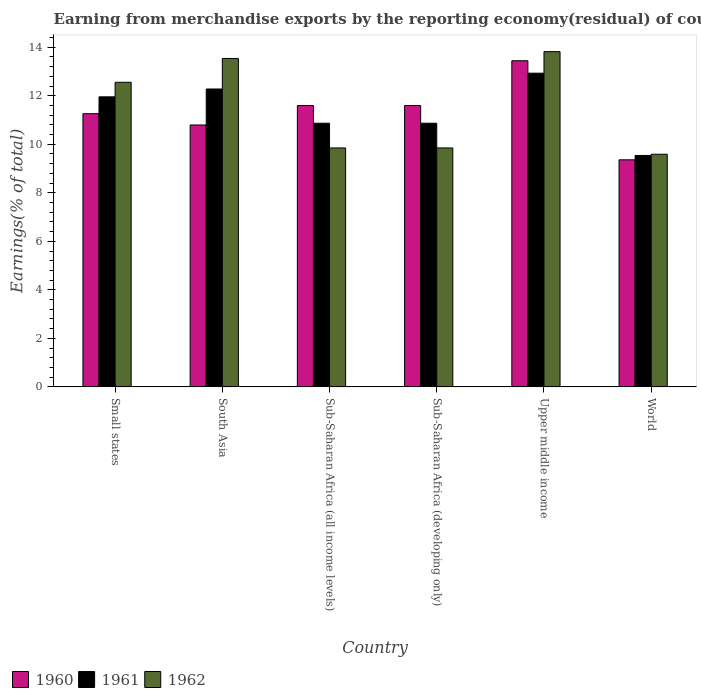How many different coloured bars are there?
Offer a very short reply. 3. How many groups of bars are there?
Your response must be concise. 6. Are the number of bars per tick equal to the number of legend labels?
Offer a very short reply. Yes. How many bars are there on the 1st tick from the left?
Offer a terse response. 3. How many bars are there on the 5th tick from the right?
Your answer should be very brief. 3. What is the label of the 6th group of bars from the left?
Ensure brevity in your answer.  World. In how many cases, is the number of bars for a given country not equal to the number of legend labels?
Provide a succinct answer. 0. What is the percentage of amount earned from merchandise exports in 1960 in World?
Keep it short and to the point. 9.36. Across all countries, what is the maximum percentage of amount earned from merchandise exports in 1960?
Keep it short and to the point. 13.44. Across all countries, what is the minimum percentage of amount earned from merchandise exports in 1961?
Make the answer very short. 9.54. In which country was the percentage of amount earned from merchandise exports in 1961 maximum?
Offer a very short reply. Upper middle income. What is the total percentage of amount earned from merchandise exports in 1961 in the graph?
Offer a very short reply. 68.44. What is the difference between the percentage of amount earned from merchandise exports in 1960 in Small states and that in Sub-Saharan Africa (all income levels)?
Offer a very short reply. -0.34. What is the difference between the percentage of amount earned from merchandise exports in 1962 in Small states and the percentage of amount earned from merchandise exports in 1961 in Upper middle income?
Keep it short and to the point. -0.38. What is the average percentage of amount earned from merchandise exports in 1960 per country?
Offer a terse response. 11.34. What is the difference between the percentage of amount earned from merchandise exports of/in 1960 and percentage of amount earned from merchandise exports of/in 1962 in Sub-Saharan Africa (all income levels)?
Your answer should be compact. 1.75. In how many countries, is the percentage of amount earned from merchandise exports in 1961 greater than 4 %?
Keep it short and to the point. 6. What is the ratio of the percentage of amount earned from merchandise exports in 1960 in Sub-Saharan Africa (developing only) to that in Upper middle income?
Offer a very short reply. 0.86. Is the percentage of amount earned from merchandise exports in 1960 in South Asia less than that in Sub-Saharan Africa (all income levels)?
Offer a terse response. Yes. What is the difference between the highest and the second highest percentage of amount earned from merchandise exports in 1962?
Ensure brevity in your answer.  0.98. What is the difference between the highest and the lowest percentage of amount earned from merchandise exports in 1961?
Make the answer very short. 3.39. In how many countries, is the percentage of amount earned from merchandise exports in 1962 greater than the average percentage of amount earned from merchandise exports in 1962 taken over all countries?
Provide a succinct answer. 3. Is the sum of the percentage of amount earned from merchandise exports in 1961 in Upper middle income and World greater than the maximum percentage of amount earned from merchandise exports in 1962 across all countries?
Your answer should be compact. Yes. What does the 2nd bar from the left in World represents?
Offer a very short reply. 1961. Is it the case that in every country, the sum of the percentage of amount earned from merchandise exports in 1962 and percentage of amount earned from merchandise exports in 1960 is greater than the percentage of amount earned from merchandise exports in 1961?
Your response must be concise. Yes. How many bars are there?
Keep it short and to the point. 18. What is the difference between two consecutive major ticks on the Y-axis?
Provide a succinct answer. 2. Does the graph contain any zero values?
Provide a succinct answer. No. Where does the legend appear in the graph?
Ensure brevity in your answer.  Bottom left. What is the title of the graph?
Keep it short and to the point. Earning from merchandise exports by the reporting economy(residual) of countries. What is the label or title of the X-axis?
Your answer should be compact. Country. What is the label or title of the Y-axis?
Offer a very short reply. Earnings(% of total). What is the Earnings(% of total) of 1960 in Small states?
Your answer should be compact. 11.26. What is the Earnings(% of total) in 1961 in Small states?
Provide a succinct answer. 11.96. What is the Earnings(% of total) of 1962 in Small states?
Provide a succinct answer. 12.56. What is the Earnings(% of total) of 1960 in South Asia?
Your answer should be very brief. 10.8. What is the Earnings(% of total) in 1961 in South Asia?
Provide a short and direct response. 12.28. What is the Earnings(% of total) in 1962 in South Asia?
Offer a terse response. 13.54. What is the Earnings(% of total) of 1960 in Sub-Saharan Africa (all income levels)?
Ensure brevity in your answer.  11.6. What is the Earnings(% of total) of 1961 in Sub-Saharan Africa (all income levels)?
Your response must be concise. 10.87. What is the Earnings(% of total) in 1962 in Sub-Saharan Africa (all income levels)?
Give a very brief answer. 9.85. What is the Earnings(% of total) of 1960 in Sub-Saharan Africa (developing only)?
Your response must be concise. 11.6. What is the Earnings(% of total) in 1961 in Sub-Saharan Africa (developing only)?
Offer a very short reply. 10.87. What is the Earnings(% of total) in 1962 in Sub-Saharan Africa (developing only)?
Your response must be concise. 9.85. What is the Earnings(% of total) of 1960 in Upper middle income?
Your answer should be compact. 13.44. What is the Earnings(% of total) in 1961 in Upper middle income?
Provide a short and direct response. 12.93. What is the Earnings(% of total) in 1962 in Upper middle income?
Provide a succinct answer. 13.82. What is the Earnings(% of total) in 1960 in World?
Your response must be concise. 9.36. What is the Earnings(% of total) in 1961 in World?
Your response must be concise. 9.54. What is the Earnings(% of total) in 1962 in World?
Provide a succinct answer. 9.59. Across all countries, what is the maximum Earnings(% of total) in 1960?
Your response must be concise. 13.44. Across all countries, what is the maximum Earnings(% of total) of 1961?
Your answer should be compact. 12.93. Across all countries, what is the maximum Earnings(% of total) in 1962?
Ensure brevity in your answer.  13.82. Across all countries, what is the minimum Earnings(% of total) of 1960?
Provide a succinct answer. 9.36. Across all countries, what is the minimum Earnings(% of total) in 1961?
Offer a terse response. 9.54. Across all countries, what is the minimum Earnings(% of total) of 1962?
Offer a terse response. 9.59. What is the total Earnings(% of total) in 1960 in the graph?
Provide a succinct answer. 68.05. What is the total Earnings(% of total) in 1961 in the graph?
Provide a succinct answer. 68.44. What is the total Earnings(% of total) of 1962 in the graph?
Keep it short and to the point. 69.2. What is the difference between the Earnings(% of total) in 1960 in Small states and that in South Asia?
Ensure brevity in your answer.  0.47. What is the difference between the Earnings(% of total) of 1961 in Small states and that in South Asia?
Your answer should be compact. -0.32. What is the difference between the Earnings(% of total) of 1962 in Small states and that in South Asia?
Ensure brevity in your answer.  -0.98. What is the difference between the Earnings(% of total) in 1960 in Small states and that in Sub-Saharan Africa (all income levels)?
Provide a short and direct response. -0.34. What is the difference between the Earnings(% of total) of 1961 in Small states and that in Sub-Saharan Africa (all income levels)?
Make the answer very short. 1.09. What is the difference between the Earnings(% of total) in 1962 in Small states and that in Sub-Saharan Africa (all income levels)?
Offer a very short reply. 2.71. What is the difference between the Earnings(% of total) of 1960 in Small states and that in Sub-Saharan Africa (developing only)?
Provide a succinct answer. -0.34. What is the difference between the Earnings(% of total) of 1961 in Small states and that in Sub-Saharan Africa (developing only)?
Make the answer very short. 1.09. What is the difference between the Earnings(% of total) of 1962 in Small states and that in Sub-Saharan Africa (developing only)?
Keep it short and to the point. 2.71. What is the difference between the Earnings(% of total) of 1960 in Small states and that in Upper middle income?
Keep it short and to the point. -2.18. What is the difference between the Earnings(% of total) of 1961 in Small states and that in Upper middle income?
Your answer should be very brief. -0.98. What is the difference between the Earnings(% of total) of 1962 in Small states and that in Upper middle income?
Provide a short and direct response. -1.26. What is the difference between the Earnings(% of total) of 1960 in Small states and that in World?
Provide a succinct answer. 1.9. What is the difference between the Earnings(% of total) of 1961 in Small states and that in World?
Offer a terse response. 2.42. What is the difference between the Earnings(% of total) of 1962 in Small states and that in World?
Your response must be concise. 2.97. What is the difference between the Earnings(% of total) of 1960 in South Asia and that in Sub-Saharan Africa (all income levels)?
Offer a very short reply. -0.8. What is the difference between the Earnings(% of total) of 1961 in South Asia and that in Sub-Saharan Africa (all income levels)?
Make the answer very short. 1.41. What is the difference between the Earnings(% of total) of 1962 in South Asia and that in Sub-Saharan Africa (all income levels)?
Provide a short and direct response. 3.69. What is the difference between the Earnings(% of total) in 1960 in South Asia and that in Sub-Saharan Africa (developing only)?
Provide a short and direct response. -0.8. What is the difference between the Earnings(% of total) in 1961 in South Asia and that in Sub-Saharan Africa (developing only)?
Offer a terse response. 1.41. What is the difference between the Earnings(% of total) in 1962 in South Asia and that in Sub-Saharan Africa (developing only)?
Your response must be concise. 3.69. What is the difference between the Earnings(% of total) in 1960 in South Asia and that in Upper middle income?
Offer a very short reply. -2.65. What is the difference between the Earnings(% of total) in 1961 in South Asia and that in Upper middle income?
Your answer should be compact. -0.65. What is the difference between the Earnings(% of total) of 1962 in South Asia and that in Upper middle income?
Provide a succinct answer. -0.28. What is the difference between the Earnings(% of total) of 1960 in South Asia and that in World?
Keep it short and to the point. 1.44. What is the difference between the Earnings(% of total) in 1961 in South Asia and that in World?
Ensure brevity in your answer.  2.74. What is the difference between the Earnings(% of total) of 1962 in South Asia and that in World?
Make the answer very short. 3.95. What is the difference between the Earnings(% of total) in 1961 in Sub-Saharan Africa (all income levels) and that in Sub-Saharan Africa (developing only)?
Your answer should be compact. 0. What is the difference between the Earnings(% of total) of 1960 in Sub-Saharan Africa (all income levels) and that in Upper middle income?
Keep it short and to the point. -1.85. What is the difference between the Earnings(% of total) in 1961 in Sub-Saharan Africa (all income levels) and that in Upper middle income?
Offer a terse response. -2.06. What is the difference between the Earnings(% of total) in 1962 in Sub-Saharan Africa (all income levels) and that in Upper middle income?
Ensure brevity in your answer.  -3.97. What is the difference between the Earnings(% of total) in 1960 in Sub-Saharan Africa (all income levels) and that in World?
Provide a succinct answer. 2.24. What is the difference between the Earnings(% of total) in 1961 in Sub-Saharan Africa (all income levels) and that in World?
Keep it short and to the point. 1.33. What is the difference between the Earnings(% of total) in 1962 in Sub-Saharan Africa (all income levels) and that in World?
Provide a succinct answer. 0.26. What is the difference between the Earnings(% of total) of 1960 in Sub-Saharan Africa (developing only) and that in Upper middle income?
Your answer should be very brief. -1.85. What is the difference between the Earnings(% of total) in 1961 in Sub-Saharan Africa (developing only) and that in Upper middle income?
Ensure brevity in your answer.  -2.06. What is the difference between the Earnings(% of total) of 1962 in Sub-Saharan Africa (developing only) and that in Upper middle income?
Give a very brief answer. -3.97. What is the difference between the Earnings(% of total) of 1960 in Sub-Saharan Africa (developing only) and that in World?
Offer a very short reply. 2.24. What is the difference between the Earnings(% of total) of 1961 in Sub-Saharan Africa (developing only) and that in World?
Give a very brief answer. 1.33. What is the difference between the Earnings(% of total) of 1962 in Sub-Saharan Africa (developing only) and that in World?
Provide a succinct answer. 0.26. What is the difference between the Earnings(% of total) in 1960 in Upper middle income and that in World?
Make the answer very short. 4.08. What is the difference between the Earnings(% of total) in 1961 in Upper middle income and that in World?
Make the answer very short. 3.39. What is the difference between the Earnings(% of total) of 1962 in Upper middle income and that in World?
Your answer should be very brief. 4.23. What is the difference between the Earnings(% of total) of 1960 in Small states and the Earnings(% of total) of 1961 in South Asia?
Your answer should be very brief. -1.02. What is the difference between the Earnings(% of total) in 1960 in Small states and the Earnings(% of total) in 1962 in South Asia?
Offer a very short reply. -2.28. What is the difference between the Earnings(% of total) of 1961 in Small states and the Earnings(% of total) of 1962 in South Asia?
Your response must be concise. -1.58. What is the difference between the Earnings(% of total) in 1960 in Small states and the Earnings(% of total) in 1961 in Sub-Saharan Africa (all income levels)?
Make the answer very short. 0.39. What is the difference between the Earnings(% of total) in 1960 in Small states and the Earnings(% of total) in 1962 in Sub-Saharan Africa (all income levels)?
Keep it short and to the point. 1.41. What is the difference between the Earnings(% of total) in 1961 in Small states and the Earnings(% of total) in 1962 in Sub-Saharan Africa (all income levels)?
Your answer should be very brief. 2.11. What is the difference between the Earnings(% of total) of 1960 in Small states and the Earnings(% of total) of 1961 in Sub-Saharan Africa (developing only)?
Offer a terse response. 0.39. What is the difference between the Earnings(% of total) in 1960 in Small states and the Earnings(% of total) in 1962 in Sub-Saharan Africa (developing only)?
Give a very brief answer. 1.41. What is the difference between the Earnings(% of total) in 1961 in Small states and the Earnings(% of total) in 1962 in Sub-Saharan Africa (developing only)?
Provide a short and direct response. 2.11. What is the difference between the Earnings(% of total) in 1960 in Small states and the Earnings(% of total) in 1961 in Upper middle income?
Offer a terse response. -1.67. What is the difference between the Earnings(% of total) of 1960 in Small states and the Earnings(% of total) of 1962 in Upper middle income?
Offer a terse response. -2.56. What is the difference between the Earnings(% of total) in 1961 in Small states and the Earnings(% of total) in 1962 in Upper middle income?
Provide a short and direct response. -1.86. What is the difference between the Earnings(% of total) in 1960 in Small states and the Earnings(% of total) in 1961 in World?
Ensure brevity in your answer.  1.72. What is the difference between the Earnings(% of total) in 1960 in Small states and the Earnings(% of total) in 1962 in World?
Ensure brevity in your answer.  1.67. What is the difference between the Earnings(% of total) of 1961 in Small states and the Earnings(% of total) of 1962 in World?
Keep it short and to the point. 2.37. What is the difference between the Earnings(% of total) in 1960 in South Asia and the Earnings(% of total) in 1961 in Sub-Saharan Africa (all income levels)?
Provide a succinct answer. -0.07. What is the difference between the Earnings(% of total) in 1960 in South Asia and the Earnings(% of total) in 1962 in Sub-Saharan Africa (all income levels)?
Make the answer very short. 0.95. What is the difference between the Earnings(% of total) of 1961 in South Asia and the Earnings(% of total) of 1962 in Sub-Saharan Africa (all income levels)?
Give a very brief answer. 2.43. What is the difference between the Earnings(% of total) in 1960 in South Asia and the Earnings(% of total) in 1961 in Sub-Saharan Africa (developing only)?
Provide a short and direct response. -0.07. What is the difference between the Earnings(% of total) of 1960 in South Asia and the Earnings(% of total) of 1962 in Sub-Saharan Africa (developing only)?
Your answer should be compact. 0.95. What is the difference between the Earnings(% of total) of 1961 in South Asia and the Earnings(% of total) of 1962 in Sub-Saharan Africa (developing only)?
Your answer should be compact. 2.43. What is the difference between the Earnings(% of total) in 1960 in South Asia and the Earnings(% of total) in 1961 in Upper middle income?
Keep it short and to the point. -2.14. What is the difference between the Earnings(% of total) of 1960 in South Asia and the Earnings(% of total) of 1962 in Upper middle income?
Your answer should be very brief. -3.02. What is the difference between the Earnings(% of total) in 1961 in South Asia and the Earnings(% of total) in 1962 in Upper middle income?
Your answer should be compact. -1.54. What is the difference between the Earnings(% of total) of 1960 in South Asia and the Earnings(% of total) of 1961 in World?
Make the answer very short. 1.26. What is the difference between the Earnings(% of total) of 1960 in South Asia and the Earnings(% of total) of 1962 in World?
Make the answer very short. 1.21. What is the difference between the Earnings(% of total) of 1961 in South Asia and the Earnings(% of total) of 1962 in World?
Offer a terse response. 2.69. What is the difference between the Earnings(% of total) of 1960 in Sub-Saharan Africa (all income levels) and the Earnings(% of total) of 1961 in Sub-Saharan Africa (developing only)?
Your response must be concise. 0.73. What is the difference between the Earnings(% of total) of 1960 in Sub-Saharan Africa (all income levels) and the Earnings(% of total) of 1962 in Sub-Saharan Africa (developing only)?
Make the answer very short. 1.75. What is the difference between the Earnings(% of total) of 1961 in Sub-Saharan Africa (all income levels) and the Earnings(% of total) of 1962 in Sub-Saharan Africa (developing only)?
Provide a short and direct response. 1.02. What is the difference between the Earnings(% of total) of 1960 in Sub-Saharan Africa (all income levels) and the Earnings(% of total) of 1961 in Upper middle income?
Ensure brevity in your answer.  -1.33. What is the difference between the Earnings(% of total) in 1960 in Sub-Saharan Africa (all income levels) and the Earnings(% of total) in 1962 in Upper middle income?
Provide a short and direct response. -2.22. What is the difference between the Earnings(% of total) in 1961 in Sub-Saharan Africa (all income levels) and the Earnings(% of total) in 1962 in Upper middle income?
Keep it short and to the point. -2.95. What is the difference between the Earnings(% of total) of 1960 in Sub-Saharan Africa (all income levels) and the Earnings(% of total) of 1961 in World?
Offer a very short reply. 2.06. What is the difference between the Earnings(% of total) of 1960 in Sub-Saharan Africa (all income levels) and the Earnings(% of total) of 1962 in World?
Give a very brief answer. 2.01. What is the difference between the Earnings(% of total) in 1961 in Sub-Saharan Africa (all income levels) and the Earnings(% of total) in 1962 in World?
Provide a short and direct response. 1.28. What is the difference between the Earnings(% of total) of 1960 in Sub-Saharan Africa (developing only) and the Earnings(% of total) of 1961 in Upper middle income?
Your response must be concise. -1.33. What is the difference between the Earnings(% of total) in 1960 in Sub-Saharan Africa (developing only) and the Earnings(% of total) in 1962 in Upper middle income?
Make the answer very short. -2.22. What is the difference between the Earnings(% of total) of 1961 in Sub-Saharan Africa (developing only) and the Earnings(% of total) of 1962 in Upper middle income?
Offer a terse response. -2.95. What is the difference between the Earnings(% of total) in 1960 in Sub-Saharan Africa (developing only) and the Earnings(% of total) in 1961 in World?
Keep it short and to the point. 2.06. What is the difference between the Earnings(% of total) in 1960 in Sub-Saharan Africa (developing only) and the Earnings(% of total) in 1962 in World?
Your response must be concise. 2.01. What is the difference between the Earnings(% of total) in 1961 in Sub-Saharan Africa (developing only) and the Earnings(% of total) in 1962 in World?
Offer a very short reply. 1.28. What is the difference between the Earnings(% of total) in 1960 in Upper middle income and the Earnings(% of total) in 1961 in World?
Your answer should be compact. 3.9. What is the difference between the Earnings(% of total) in 1960 in Upper middle income and the Earnings(% of total) in 1962 in World?
Ensure brevity in your answer.  3.85. What is the difference between the Earnings(% of total) of 1961 in Upper middle income and the Earnings(% of total) of 1962 in World?
Keep it short and to the point. 3.34. What is the average Earnings(% of total) in 1960 per country?
Provide a succinct answer. 11.34. What is the average Earnings(% of total) in 1961 per country?
Make the answer very short. 11.41. What is the average Earnings(% of total) in 1962 per country?
Keep it short and to the point. 11.53. What is the difference between the Earnings(% of total) in 1960 and Earnings(% of total) in 1961 in Small states?
Offer a terse response. -0.69. What is the difference between the Earnings(% of total) in 1960 and Earnings(% of total) in 1962 in Small states?
Provide a short and direct response. -1.29. What is the difference between the Earnings(% of total) in 1961 and Earnings(% of total) in 1962 in Small states?
Make the answer very short. -0.6. What is the difference between the Earnings(% of total) of 1960 and Earnings(% of total) of 1961 in South Asia?
Give a very brief answer. -1.48. What is the difference between the Earnings(% of total) of 1960 and Earnings(% of total) of 1962 in South Asia?
Offer a terse response. -2.74. What is the difference between the Earnings(% of total) of 1961 and Earnings(% of total) of 1962 in South Asia?
Provide a succinct answer. -1.26. What is the difference between the Earnings(% of total) in 1960 and Earnings(% of total) in 1961 in Sub-Saharan Africa (all income levels)?
Your answer should be compact. 0.73. What is the difference between the Earnings(% of total) in 1960 and Earnings(% of total) in 1962 in Sub-Saharan Africa (all income levels)?
Keep it short and to the point. 1.75. What is the difference between the Earnings(% of total) in 1961 and Earnings(% of total) in 1962 in Sub-Saharan Africa (all income levels)?
Offer a terse response. 1.02. What is the difference between the Earnings(% of total) of 1960 and Earnings(% of total) of 1961 in Sub-Saharan Africa (developing only)?
Your answer should be very brief. 0.73. What is the difference between the Earnings(% of total) in 1960 and Earnings(% of total) in 1962 in Sub-Saharan Africa (developing only)?
Ensure brevity in your answer.  1.75. What is the difference between the Earnings(% of total) in 1961 and Earnings(% of total) in 1962 in Sub-Saharan Africa (developing only)?
Keep it short and to the point. 1.02. What is the difference between the Earnings(% of total) of 1960 and Earnings(% of total) of 1961 in Upper middle income?
Make the answer very short. 0.51. What is the difference between the Earnings(% of total) of 1960 and Earnings(% of total) of 1962 in Upper middle income?
Give a very brief answer. -0.38. What is the difference between the Earnings(% of total) in 1961 and Earnings(% of total) in 1962 in Upper middle income?
Provide a short and direct response. -0.89. What is the difference between the Earnings(% of total) in 1960 and Earnings(% of total) in 1961 in World?
Offer a very short reply. -0.18. What is the difference between the Earnings(% of total) in 1960 and Earnings(% of total) in 1962 in World?
Ensure brevity in your answer.  -0.23. What is the difference between the Earnings(% of total) in 1961 and Earnings(% of total) in 1962 in World?
Your answer should be compact. -0.05. What is the ratio of the Earnings(% of total) of 1960 in Small states to that in South Asia?
Your answer should be very brief. 1.04. What is the ratio of the Earnings(% of total) of 1961 in Small states to that in South Asia?
Make the answer very short. 0.97. What is the ratio of the Earnings(% of total) of 1962 in Small states to that in South Asia?
Ensure brevity in your answer.  0.93. What is the ratio of the Earnings(% of total) of 1960 in Small states to that in Sub-Saharan Africa (all income levels)?
Provide a succinct answer. 0.97. What is the ratio of the Earnings(% of total) in 1961 in Small states to that in Sub-Saharan Africa (all income levels)?
Provide a succinct answer. 1.1. What is the ratio of the Earnings(% of total) of 1962 in Small states to that in Sub-Saharan Africa (all income levels)?
Provide a succinct answer. 1.27. What is the ratio of the Earnings(% of total) in 1960 in Small states to that in Sub-Saharan Africa (developing only)?
Offer a terse response. 0.97. What is the ratio of the Earnings(% of total) of 1961 in Small states to that in Sub-Saharan Africa (developing only)?
Provide a short and direct response. 1.1. What is the ratio of the Earnings(% of total) in 1962 in Small states to that in Sub-Saharan Africa (developing only)?
Keep it short and to the point. 1.27. What is the ratio of the Earnings(% of total) of 1960 in Small states to that in Upper middle income?
Your answer should be compact. 0.84. What is the ratio of the Earnings(% of total) of 1961 in Small states to that in Upper middle income?
Provide a short and direct response. 0.92. What is the ratio of the Earnings(% of total) of 1962 in Small states to that in Upper middle income?
Your answer should be very brief. 0.91. What is the ratio of the Earnings(% of total) of 1960 in Small states to that in World?
Provide a short and direct response. 1.2. What is the ratio of the Earnings(% of total) of 1961 in Small states to that in World?
Provide a short and direct response. 1.25. What is the ratio of the Earnings(% of total) of 1962 in Small states to that in World?
Make the answer very short. 1.31. What is the ratio of the Earnings(% of total) in 1960 in South Asia to that in Sub-Saharan Africa (all income levels)?
Give a very brief answer. 0.93. What is the ratio of the Earnings(% of total) of 1961 in South Asia to that in Sub-Saharan Africa (all income levels)?
Make the answer very short. 1.13. What is the ratio of the Earnings(% of total) in 1962 in South Asia to that in Sub-Saharan Africa (all income levels)?
Offer a terse response. 1.37. What is the ratio of the Earnings(% of total) of 1960 in South Asia to that in Sub-Saharan Africa (developing only)?
Your response must be concise. 0.93. What is the ratio of the Earnings(% of total) of 1961 in South Asia to that in Sub-Saharan Africa (developing only)?
Offer a terse response. 1.13. What is the ratio of the Earnings(% of total) in 1962 in South Asia to that in Sub-Saharan Africa (developing only)?
Provide a succinct answer. 1.37. What is the ratio of the Earnings(% of total) in 1960 in South Asia to that in Upper middle income?
Your answer should be compact. 0.8. What is the ratio of the Earnings(% of total) of 1961 in South Asia to that in Upper middle income?
Offer a very short reply. 0.95. What is the ratio of the Earnings(% of total) of 1962 in South Asia to that in Upper middle income?
Give a very brief answer. 0.98. What is the ratio of the Earnings(% of total) of 1960 in South Asia to that in World?
Your answer should be very brief. 1.15. What is the ratio of the Earnings(% of total) in 1961 in South Asia to that in World?
Your answer should be very brief. 1.29. What is the ratio of the Earnings(% of total) in 1962 in South Asia to that in World?
Give a very brief answer. 1.41. What is the ratio of the Earnings(% of total) of 1960 in Sub-Saharan Africa (all income levels) to that in Upper middle income?
Your response must be concise. 0.86. What is the ratio of the Earnings(% of total) of 1961 in Sub-Saharan Africa (all income levels) to that in Upper middle income?
Provide a succinct answer. 0.84. What is the ratio of the Earnings(% of total) in 1962 in Sub-Saharan Africa (all income levels) to that in Upper middle income?
Provide a succinct answer. 0.71. What is the ratio of the Earnings(% of total) in 1960 in Sub-Saharan Africa (all income levels) to that in World?
Your response must be concise. 1.24. What is the ratio of the Earnings(% of total) of 1961 in Sub-Saharan Africa (all income levels) to that in World?
Provide a short and direct response. 1.14. What is the ratio of the Earnings(% of total) in 1962 in Sub-Saharan Africa (all income levels) to that in World?
Make the answer very short. 1.03. What is the ratio of the Earnings(% of total) in 1960 in Sub-Saharan Africa (developing only) to that in Upper middle income?
Provide a short and direct response. 0.86. What is the ratio of the Earnings(% of total) of 1961 in Sub-Saharan Africa (developing only) to that in Upper middle income?
Provide a short and direct response. 0.84. What is the ratio of the Earnings(% of total) in 1962 in Sub-Saharan Africa (developing only) to that in Upper middle income?
Provide a succinct answer. 0.71. What is the ratio of the Earnings(% of total) in 1960 in Sub-Saharan Africa (developing only) to that in World?
Offer a terse response. 1.24. What is the ratio of the Earnings(% of total) of 1961 in Sub-Saharan Africa (developing only) to that in World?
Make the answer very short. 1.14. What is the ratio of the Earnings(% of total) in 1962 in Sub-Saharan Africa (developing only) to that in World?
Your response must be concise. 1.03. What is the ratio of the Earnings(% of total) of 1960 in Upper middle income to that in World?
Your answer should be very brief. 1.44. What is the ratio of the Earnings(% of total) of 1961 in Upper middle income to that in World?
Provide a succinct answer. 1.36. What is the ratio of the Earnings(% of total) of 1962 in Upper middle income to that in World?
Provide a short and direct response. 1.44. What is the difference between the highest and the second highest Earnings(% of total) of 1960?
Keep it short and to the point. 1.85. What is the difference between the highest and the second highest Earnings(% of total) in 1961?
Your answer should be compact. 0.65. What is the difference between the highest and the second highest Earnings(% of total) of 1962?
Keep it short and to the point. 0.28. What is the difference between the highest and the lowest Earnings(% of total) of 1960?
Offer a terse response. 4.08. What is the difference between the highest and the lowest Earnings(% of total) in 1961?
Provide a short and direct response. 3.39. What is the difference between the highest and the lowest Earnings(% of total) of 1962?
Your answer should be compact. 4.23. 